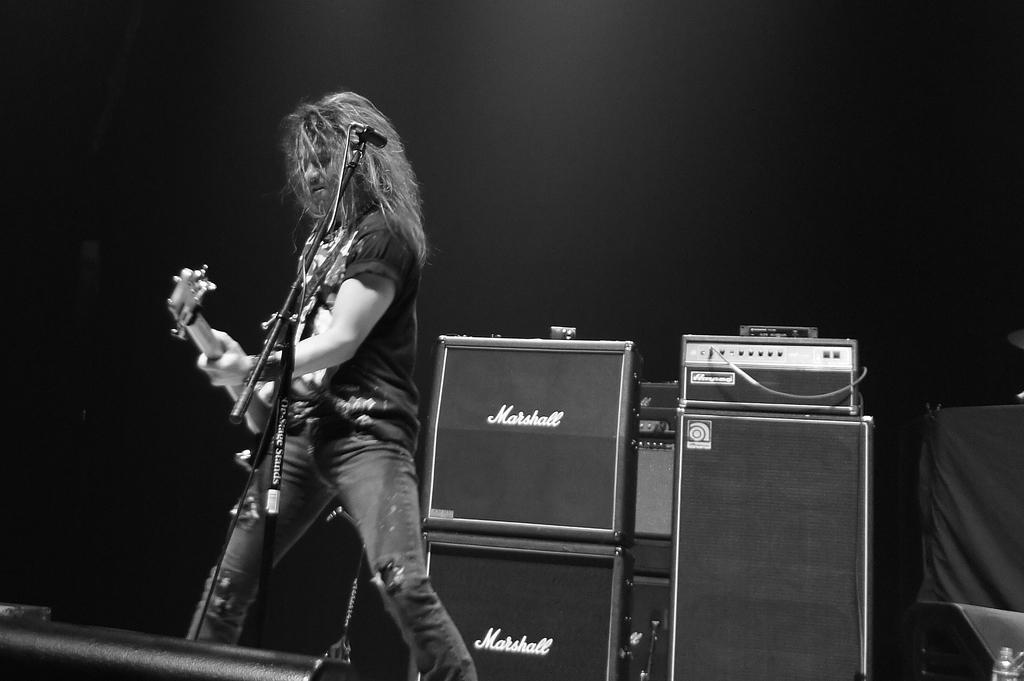<image>
Share a concise interpretation of the image provided. A guitar player on stage in fromt of Marshall amplifiers. 